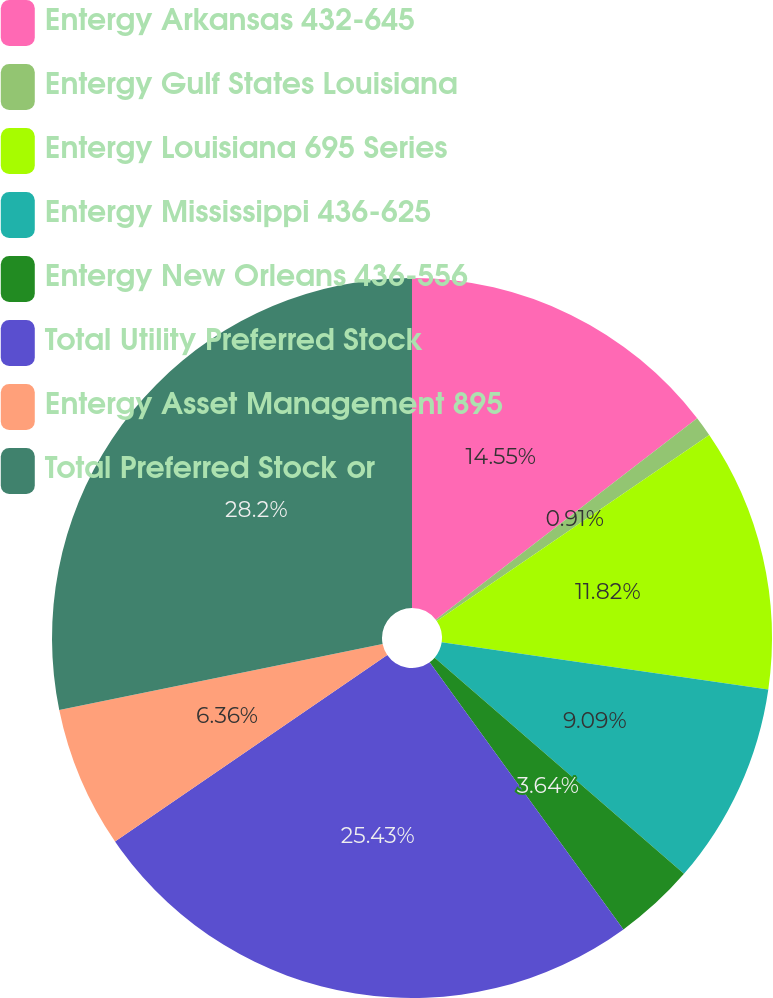Convert chart. <chart><loc_0><loc_0><loc_500><loc_500><pie_chart><fcel>Entergy Arkansas 432-645<fcel>Entergy Gulf States Louisiana<fcel>Entergy Louisiana 695 Series<fcel>Entergy Mississippi 436-625<fcel>Entergy New Orleans 436-556<fcel>Total Utility Preferred Stock<fcel>Entergy Asset Management 895<fcel>Total Preferred Stock or<nl><fcel>14.55%<fcel>0.91%<fcel>11.82%<fcel>9.09%<fcel>3.64%<fcel>25.43%<fcel>6.36%<fcel>28.2%<nl></chart> 